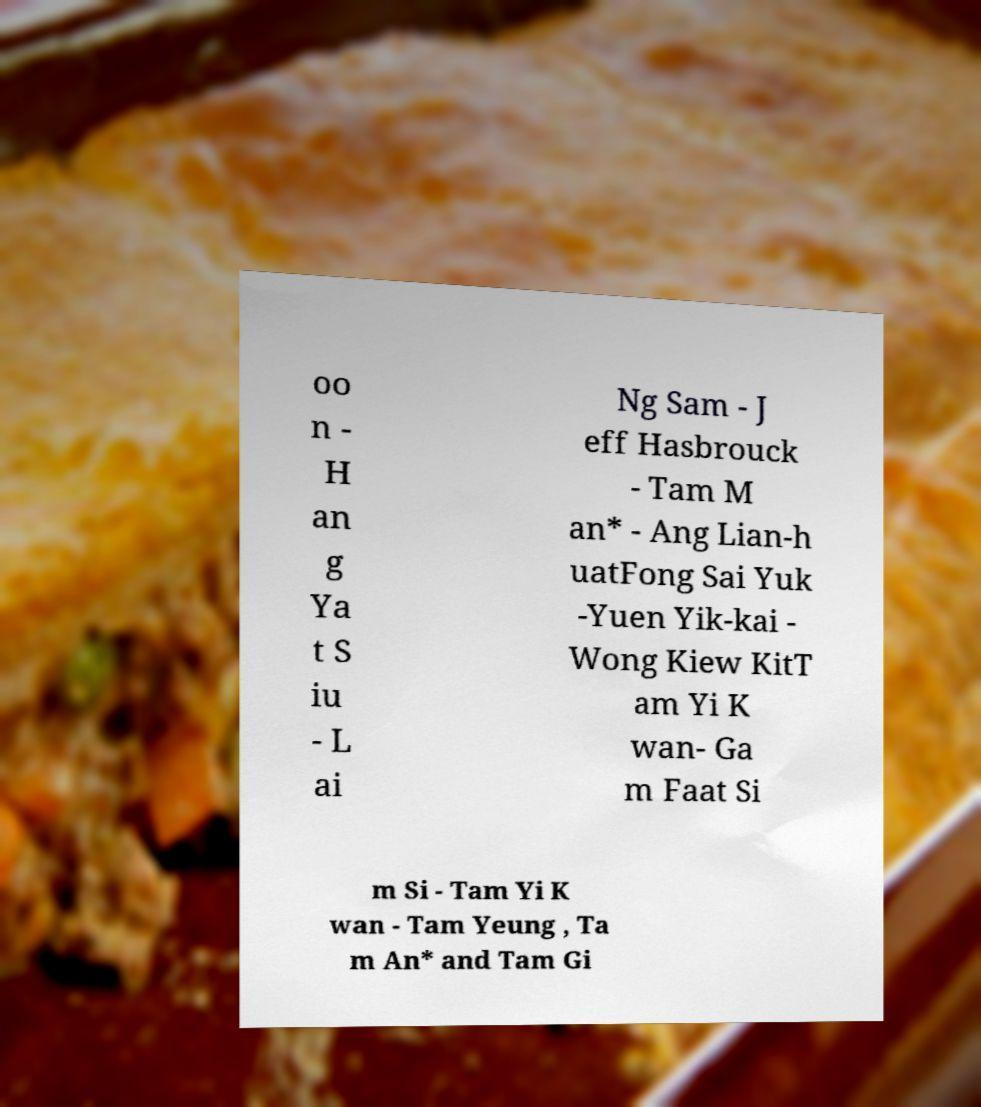For documentation purposes, I need the text within this image transcribed. Could you provide that? oo n - H an g Ya t S iu - L ai Ng Sam - J eff Hasbrouck - Tam M an* - Ang Lian-h uatFong Sai Yuk -Yuen Yik-kai - Wong Kiew KitT am Yi K wan- Ga m Faat Si m Si - Tam Yi K wan - Tam Yeung , Ta m An* and Tam Gi 